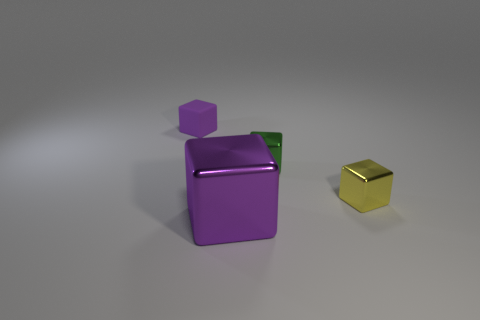What size is the yellow thing that is the same material as the large block?
Your answer should be compact. Small. What number of small shiny spheres have the same color as the rubber thing?
Provide a succinct answer. 0. Is the number of yellow objects to the left of the big purple metallic thing less than the number of tiny yellow things to the left of the green block?
Offer a terse response. No. There is a purple object to the right of the small purple cube; what is its size?
Keep it short and to the point. Large. The block that is the same color as the big object is what size?
Give a very brief answer. Small. Are there any small blue objects that have the same material as the large purple thing?
Your answer should be compact. No. Is the material of the green cube the same as the tiny yellow cube?
Your response must be concise. Yes. The shiny cube that is the same size as the green object is what color?
Offer a very short reply. Yellow. What number of other objects are there of the same shape as the small purple thing?
Provide a succinct answer. 3. There is a yellow object; is it the same size as the metal thing that is behind the yellow metallic block?
Provide a succinct answer. Yes. 